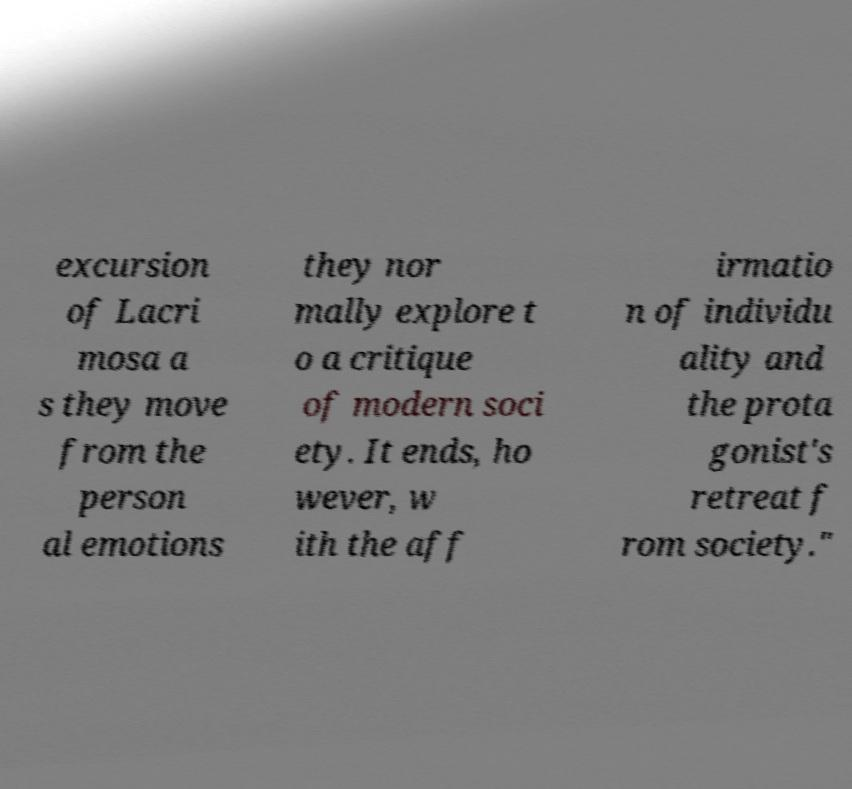Please identify and transcribe the text found in this image. excursion of Lacri mosa a s they move from the person al emotions they nor mally explore t o a critique of modern soci ety. It ends, ho wever, w ith the aff irmatio n of individu ality and the prota gonist's retreat f rom society." 